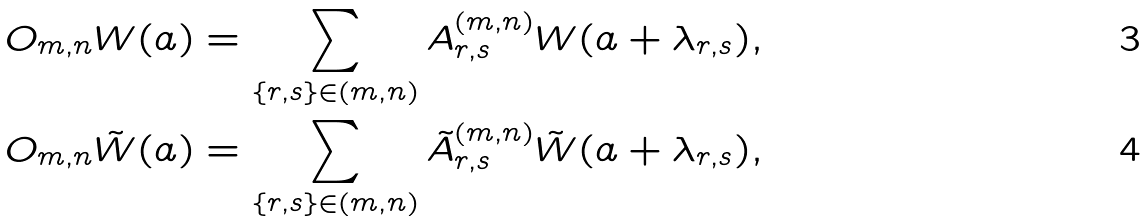Convert formula to latex. <formula><loc_0><loc_0><loc_500><loc_500>O _ { m , n } W ( a ) & = \sum _ { \{ r , s \} \in ( m , n ) } A _ { r , s } ^ { ( m , n ) } W ( a + \lambda _ { r , s } ) , \\ O _ { m , n } \tilde { W } ( a ) & = \sum _ { \{ r , s \} \in ( m , n ) } \tilde { A } _ { r , s } ^ { ( m , n ) } \tilde { W } ( a + \lambda _ { r , s } ) ,</formula> 